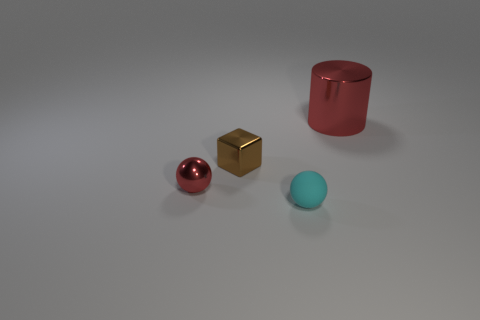Subtract all cylinders. How many objects are left? 3 Subtract all red spheres. How many spheres are left? 1 Subtract 1 red balls. How many objects are left? 3 Subtract 1 cylinders. How many cylinders are left? 0 Subtract all green blocks. Subtract all yellow balls. How many blocks are left? 1 Subtract all green cubes. How many gray cylinders are left? 0 Subtract all tiny brown shiny things. Subtract all red balls. How many objects are left? 2 Add 2 tiny cyan spheres. How many tiny cyan spheres are left? 3 Add 1 large cyan rubber spheres. How many large cyan rubber spheres exist? 1 Add 2 cyan spheres. How many objects exist? 6 